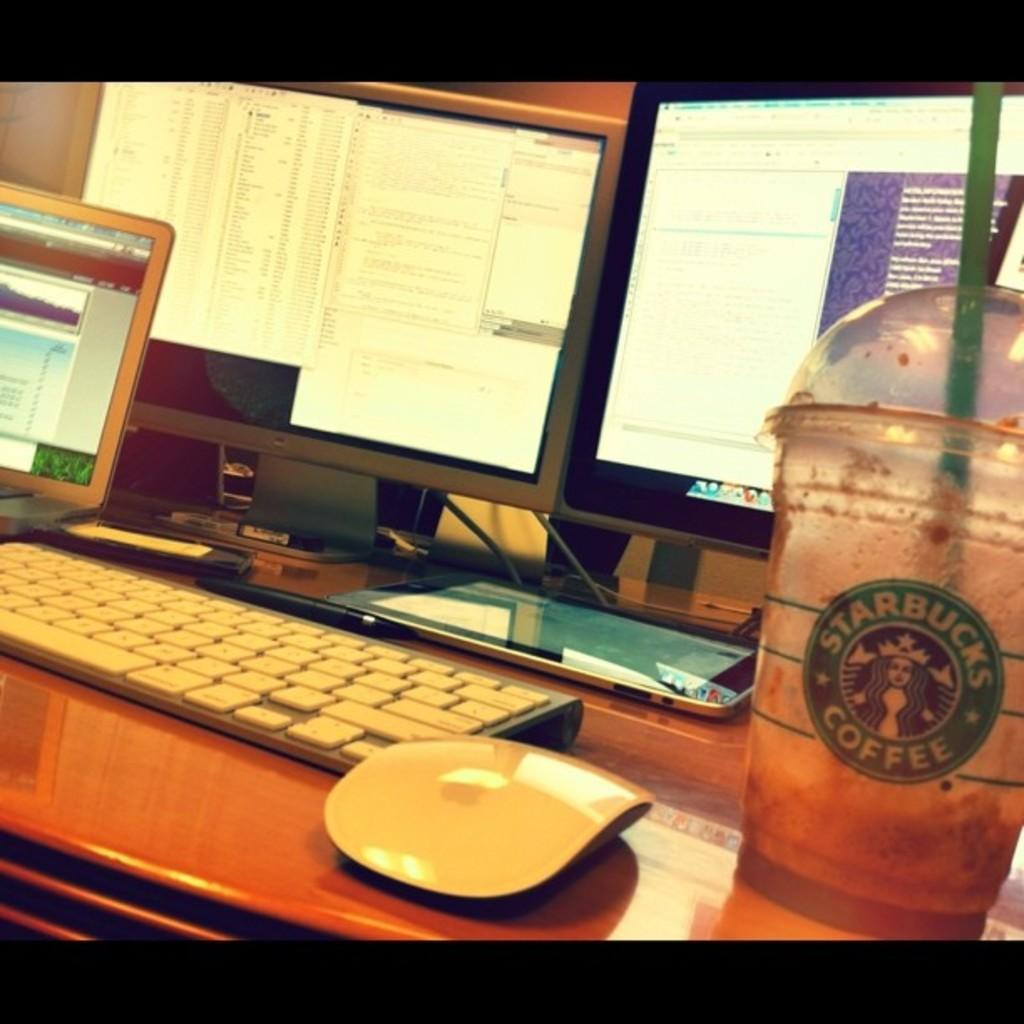What type of coffee cup is visible in the image? There is a Starbucks coffee cup in the image. What is the color of the keyboard in the image? The keyboard in the image is white. What device is used for input alongside the keyboard? There is a mouse in the image. What type of surface is the keyboard and mouse placed on? The keyboard and mouse are on a wooden table. How many computer screens can be seen in the background? There are three computer screens visible in the background. Where is the baby located in the image? There is no baby present in the image. What type of structure is visible in the background? The image does not show any structures in the background; it primarily features a keyboard, mouse, and computer screens. 